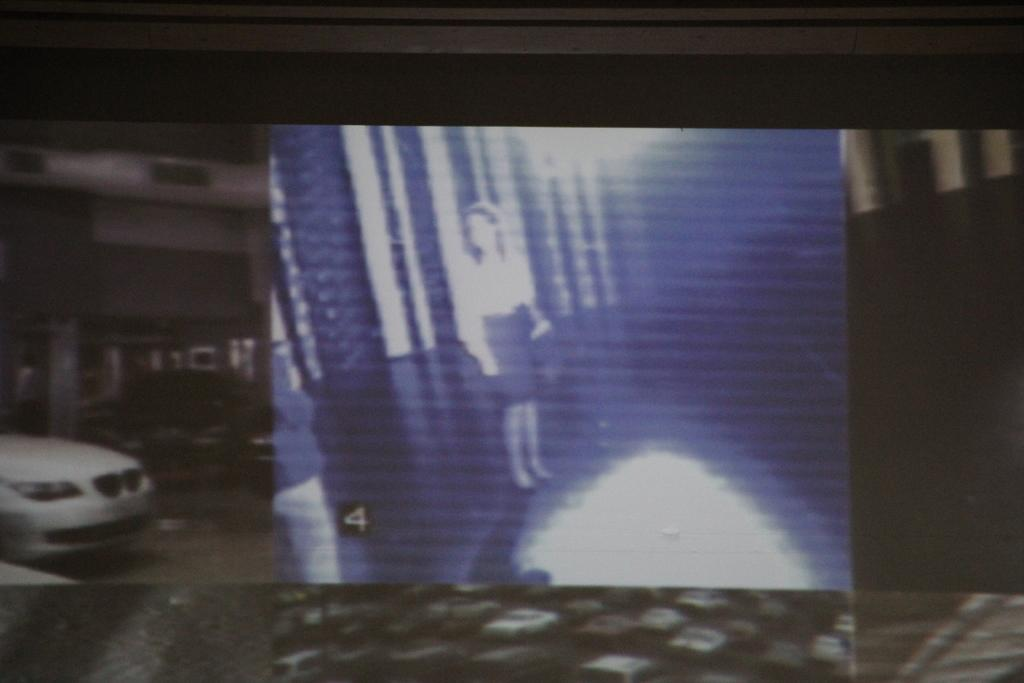What types of subjects can be seen in the image? There are people and vehicles in the image. Can you describe the people in the image? Unfortunately, the provided facts do not give any specific details about the people in the image. What types of vehicles are present in the image? The provided facts do not give any specific details about the vehicles in the image. What type of curve can be seen in the image? There is no curve present in the image. Is there a baby visible in the image? There is no mention of a baby in the provided facts, so we cannot determine if one is present in the image. 